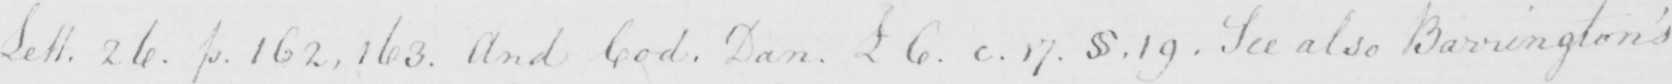What is written in this line of handwriting? Lett . 26 . p . 162 , 163 . And Cod . Dan . L 6 . c . 17 .  § . 19 . See also Barrington ' s 